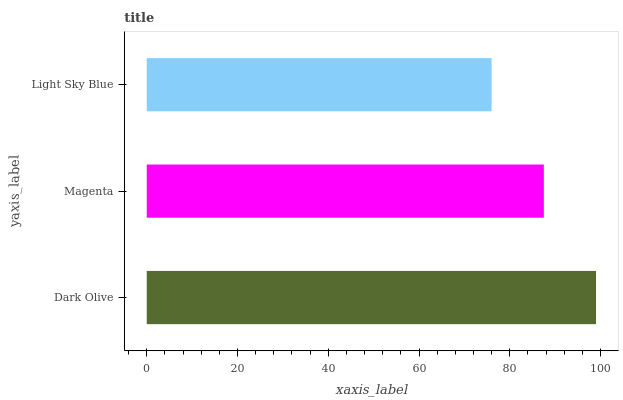Is Light Sky Blue the minimum?
Answer yes or no. Yes. Is Dark Olive the maximum?
Answer yes or no. Yes. Is Magenta the minimum?
Answer yes or no. No. Is Magenta the maximum?
Answer yes or no. No. Is Dark Olive greater than Magenta?
Answer yes or no. Yes. Is Magenta less than Dark Olive?
Answer yes or no. Yes. Is Magenta greater than Dark Olive?
Answer yes or no. No. Is Dark Olive less than Magenta?
Answer yes or no. No. Is Magenta the high median?
Answer yes or no. Yes. Is Magenta the low median?
Answer yes or no. Yes. Is Dark Olive the high median?
Answer yes or no. No. Is Dark Olive the low median?
Answer yes or no. No. 